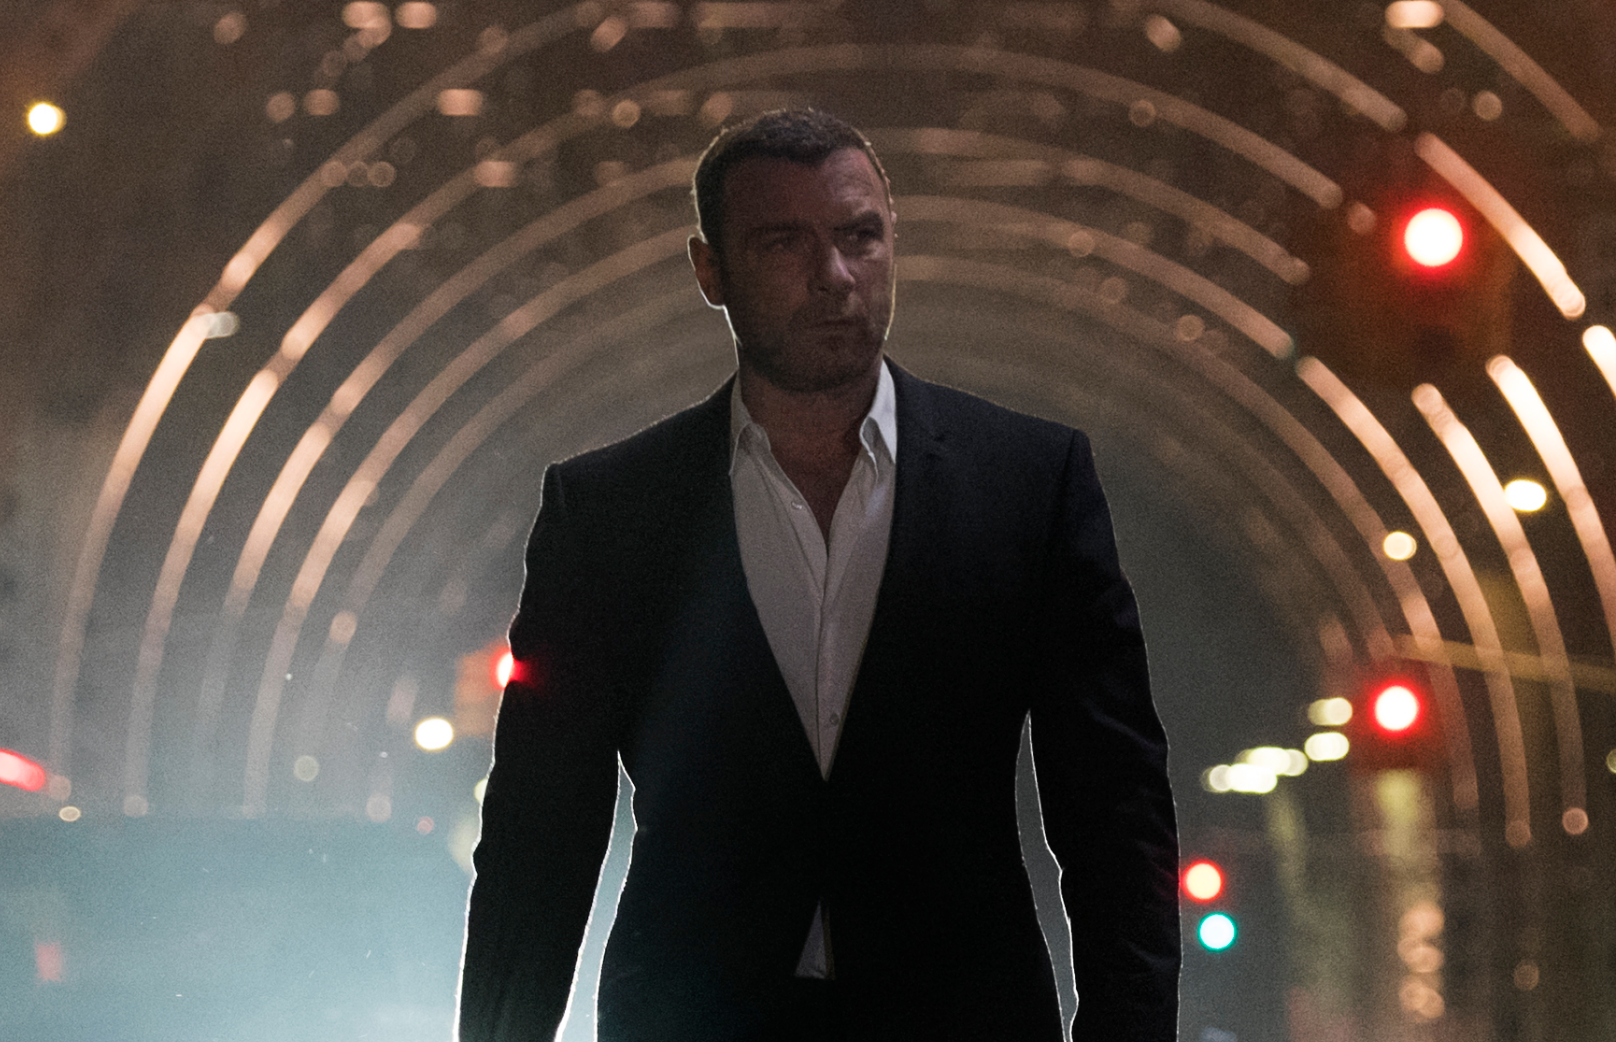How would you describe the mood of this scene? The mood of the scene is somber and intense. There's a sense of isolation as the figure walks alone, and the cool color palette along with the contrast between light and shadow contribute to a feeling of contemplation and perhaps inner conflict. The urban setting at night adds to the air of mystery and drama. 